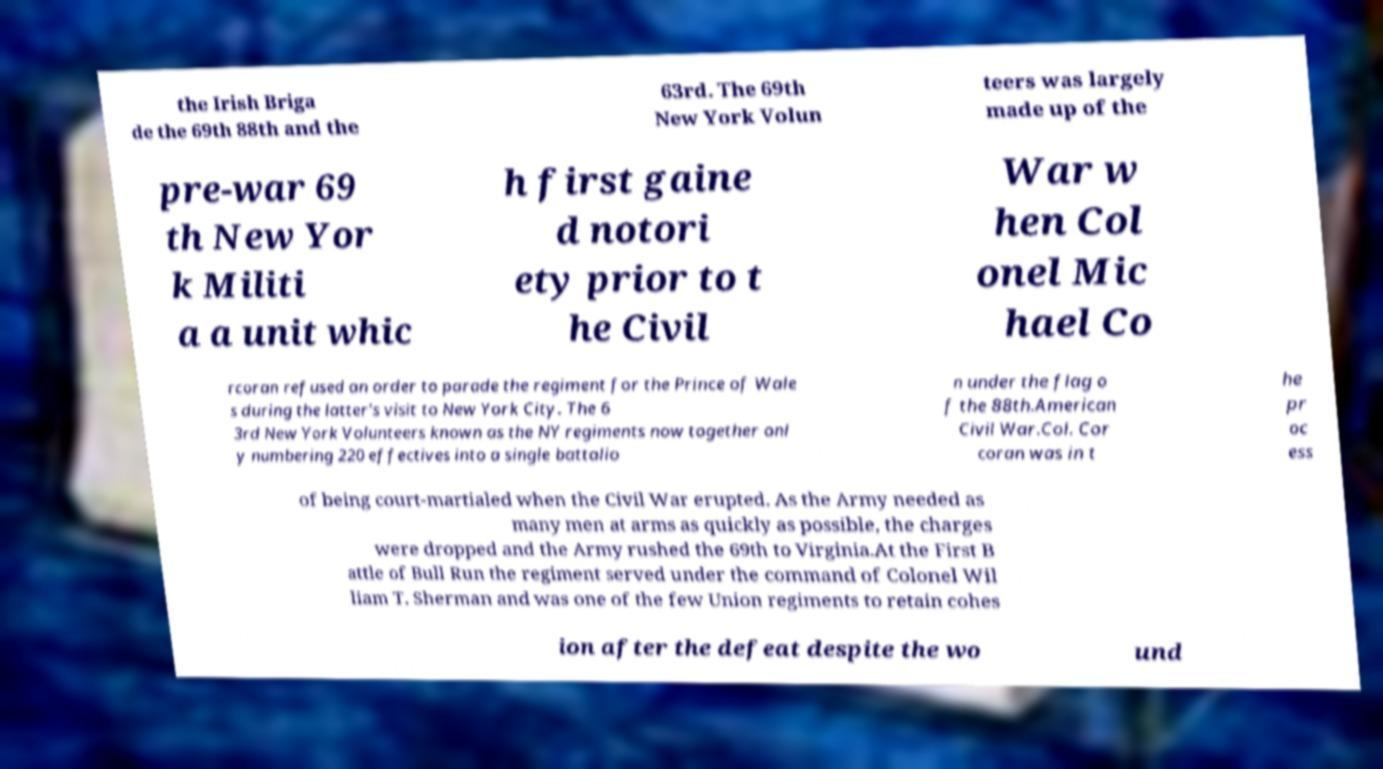For documentation purposes, I need the text within this image transcribed. Could you provide that? the Irish Briga de the 69th 88th and the 63rd. The 69th New York Volun teers was largely made up of the pre-war 69 th New Yor k Militi a a unit whic h first gaine d notori ety prior to t he Civil War w hen Col onel Mic hael Co rcoran refused an order to parade the regiment for the Prince of Wale s during the latter's visit to New York City. The 6 3rd New York Volunteers known as the NY regiments now together onl y numbering 220 effectives into a single battalio n under the flag o f the 88th.American Civil War.Col. Cor coran was in t he pr oc ess of being court-martialed when the Civil War erupted. As the Army needed as many men at arms as quickly as possible, the charges were dropped and the Army rushed the 69th to Virginia.At the First B attle of Bull Run the regiment served under the command of Colonel Wil liam T. Sherman and was one of the few Union regiments to retain cohes ion after the defeat despite the wo und 